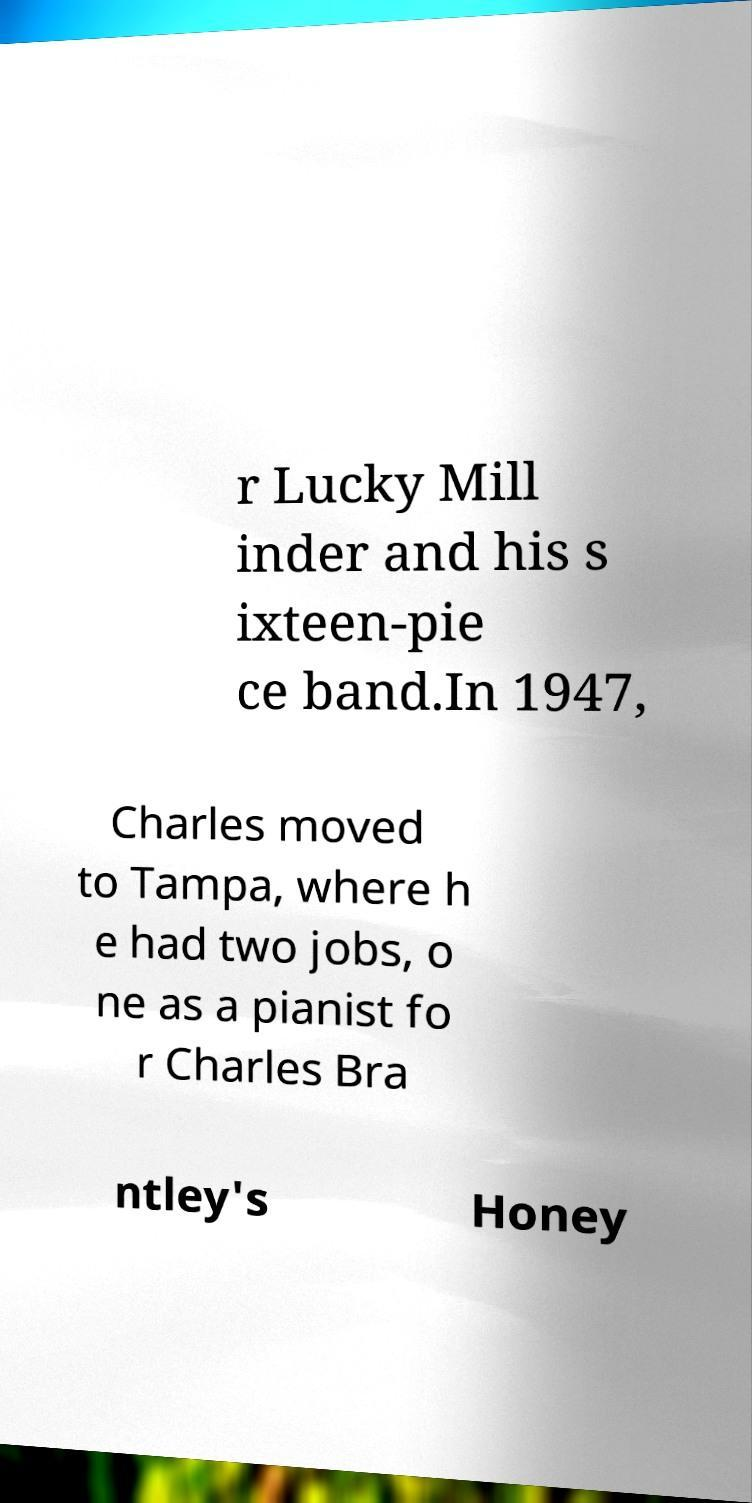For documentation purposes, I need the text within this image transcribed. Could you provide that? r Lucky Mill inder and his s ixteen-pie ce band.In 1947, Charles moved to Tampa, where h e had two jobs, o ne as a pianist fo r Charles Bra ntley's Honey 